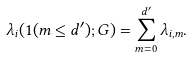Convert formula to latex. <formula><loc_0><loc_0><loc_500><loc_500>\lambda _ { i } ( { 1 } ( m \leq d ^ { \prime } ) ; G ) = \sum _ { m = 0 } ^ { d ^ { \prime } } \lambda _ { i , m } .</formula> 